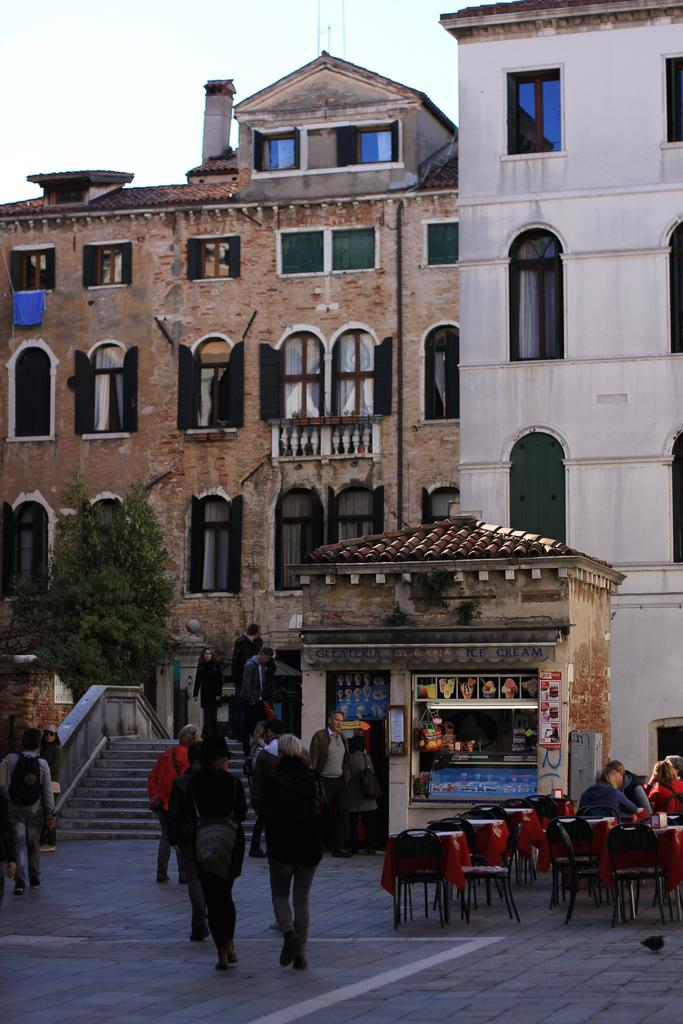What is happening in the image involving the group of people? The people are walking towards a building in the image. What can be seen beside the group of people? Chairs and tables are present beside the group of people. Can you describe the building in the image? The building has many windows. What type of hammer is being used by the person in the image? There is no hammer present in the image; the people are walking towards a building. 